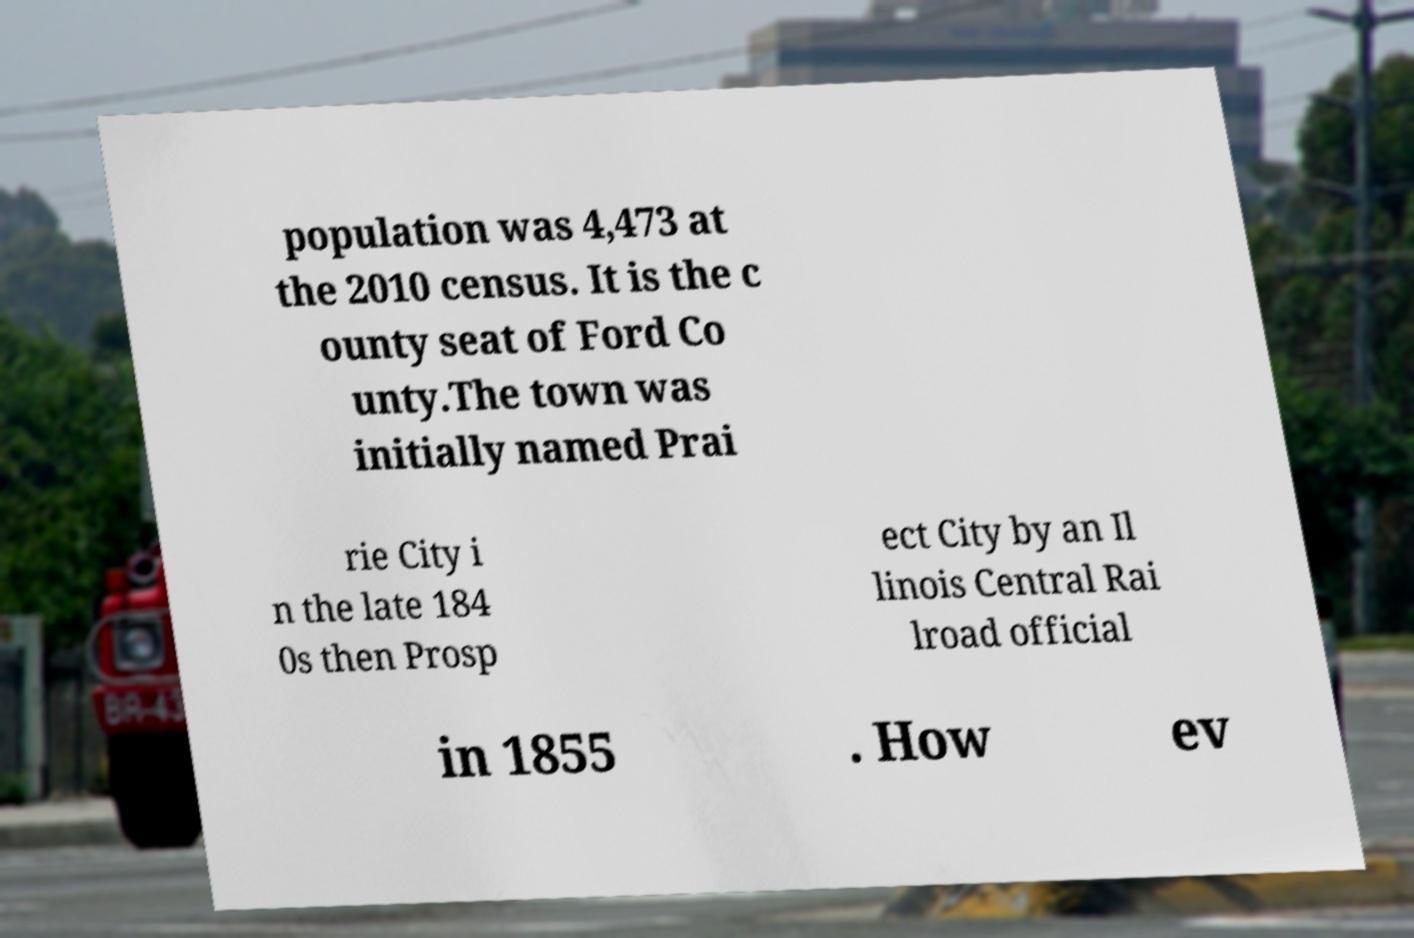Could you assist in decoding the text presented in this image and type it out clearly? population was 4,473 at the 2010 census. It is the c ounty seat of Ford Co unty.The town was initially named Prai rie City i n the late 184 0s then Prosp ect City by an Il linois Central Rai lroad official in 1855 . How ev 